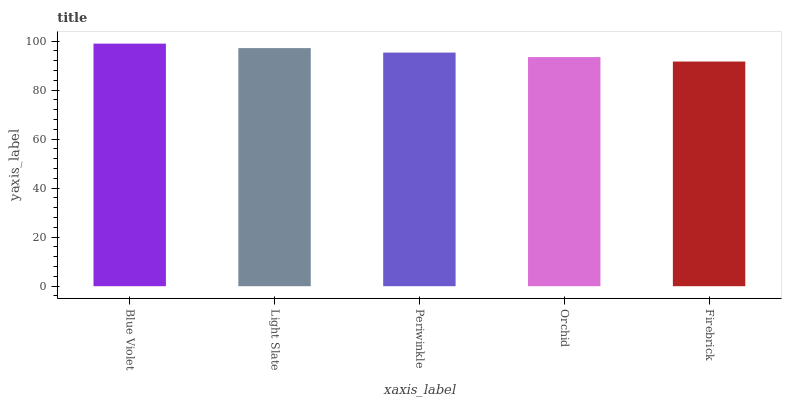Is Firebrick the minimum?
Answer yes or no. Yes. Is Blue Violet the maximum?
Answer yes or no. Yes. Is Light Slate the minimum?
Answer yes or no. No. Is Light Slate the maximum?
Answer yes or no. No. Is Blue Violet greater than Light Slate?
Answer yes or no. Yes. Is Light Slate less than Blue Violet?
Answer yes or no. Yes. Is Light Slate greater than Blue Violet?
Answer yes or no. No. Is Blue Violet less than Light Slate?
Answer yes or no. No. Is Periwinkle the high median?
Answer yes or no. Yes. Is Periwinkle the low median?
Answer yes or no. Yes. Is Orchid the high median?
Answer yes or no. No. Is Firebrick the low median?
Answer yes or no. No. 